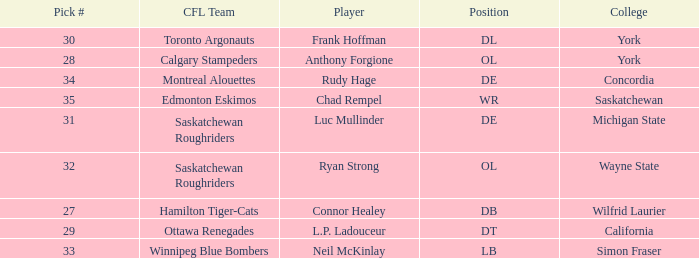What is the Pick # for Ryan Strong? 32.0. 